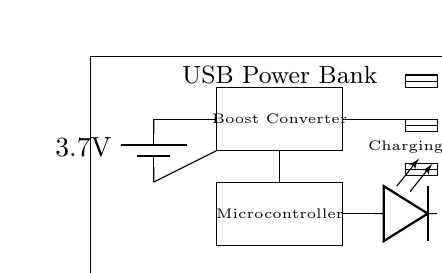What is the voltage of the battery? The voltage of the battery is indicated as 3.7 volts in the circuit diagram, which is marked next to the battery symbol.
Answer: 3.7 volts What type of converter is present in the circuit? The circuit includes a boost converter, as indicated by the labeled rectangle containing the text "Boost Converter." This type of converter is responsible for increasing the voltage output from the battery.
Answer: Boost converter How many USB ports are available? The circuit diagram shows three USB port rectangles, each labeled with a unique identifier (USB 1, USB 2, USB 3). This indicates that the power bank can charge three devices simultaneously.
Answer: Three What is the function of the LED? The LED labeled "Charging" in the circuit serves as an indicator to show when the power bank is actively charging a device. This is evident from its connection to the output of the boost converter.
Answer: Charging indicator How does the microcontroller relate to the boost converter? The microcontroller is connected to the boost converter through a line that indicates control or monitoring functions. This suggests that the microcontroller regulates or manages the power output from the boost converter to the USB ports.
Answer: Regulates output What is the main purpose of this circuit? The primary purpose of this circuit is to function as a USB power bank, allowing it to charge multiple devices on-the-go. This is supported by the presence of multiple USB ports connected to the power output from the boost converter.
Answer: USB power bank 